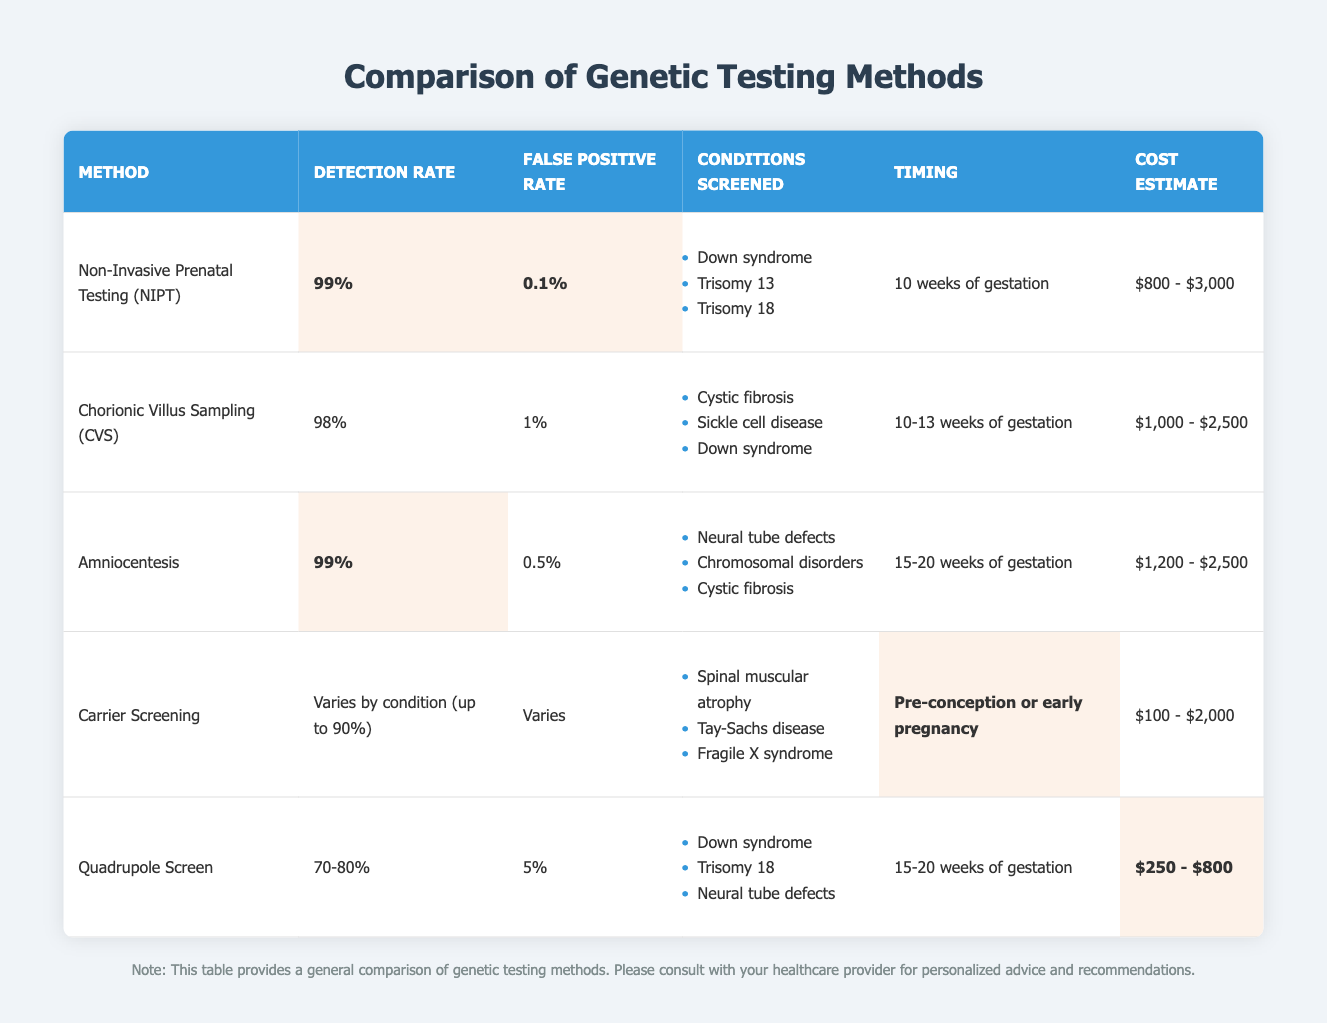What is the detection rate of Non-Invasive Prenatal Testing (NIPT)? The table states that the detection rate for NIPT is highlighted at 99%.
Answer: 99% What is the false positive rate for Amniocentesis? The false positive rate for Amniocentesis is listed as 0.5%.
Answer: 0.5% Does Carrier Screening have a detection rate that varies by condition? Yes, the table indicates that Carrier Screening's detection rate varies by condition, up to 90%.
Answer: Yes Which testing method has the lowest cost estimate? By comparing cost estimates, Carrier Screening has the lowest range at $100 - $2,000.
Answer: Carrier Screening What is the average detection rate of the methods listed in the table? The detection rates to average are: NIPT 99%, CVS 98%, Amniocentesis 99%, Carrier Screening up to 90% (taking 90% for calculation), and Quadrupole Screen averaging 75%. Thus, the average is (99 + 98 + 99 + 90 + 75) / 5 = 92.2%.
Answer: 92.2% What conditions are screened by the method with the highest detection rate? The method with the highest detection rate, NIPT, screens for Down syndrome, Trisomy 13, and Trisomy 18.
Answer: Down syndrome, Trisomy 13, Trisomy 18 Is it true that the Quadrupole Screen has a higher false positive rate than CVS? Yes, according to the table, the false positive rate for Quadrupole Screen is 5%, while for CVS it is 1%.
Answer: Yes Which method can be performed the earliest during pregnancy? The table shows that Carrier Screening can be performed pre-conception or in early pregnancy, making it the earliest method.
Answer: Carrier Screening What is the difference between the detection rates of NIPT and CVS? The detection rate of NIPT is 99%, and CVS is 98%, so the difference is 99% - 98% = 1%.
Answer: 1% What cost estimate range does Amniocentesis fall under? Amniocentesis has a cost estimate range of $1,200 - $2,500 according to the table.
Answer: $1,200 - $2,500 